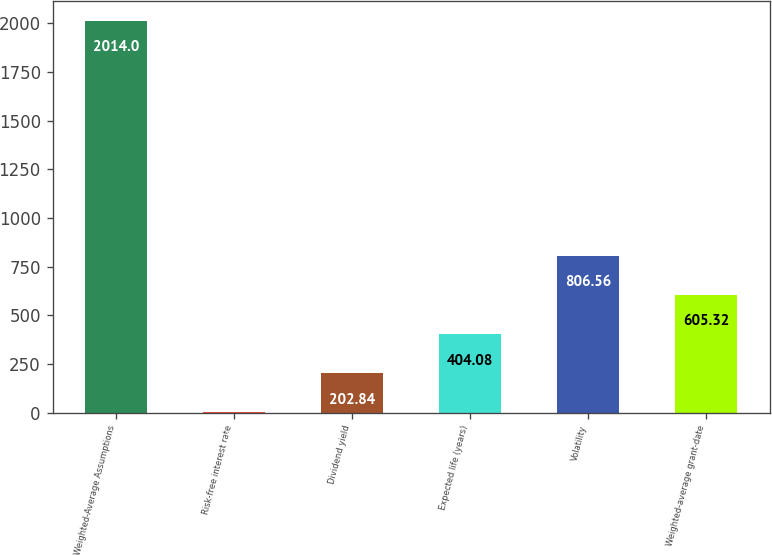<chart> <loc_0><loc_0><loc_500><loc_500><bar_chart><fcel>Weighted-Average Assumptions<fcel>Risk-free interest rate<fcel>Dividend yield<fcel>Expected life (years)<fcel>Volatility<fcel>Weighted-average grant-date<nl><fcel>2014<fcel>1.6<fcel>202.84<fcel>404.08<fcel>806.56<fcel>605.32<nl></chart> 